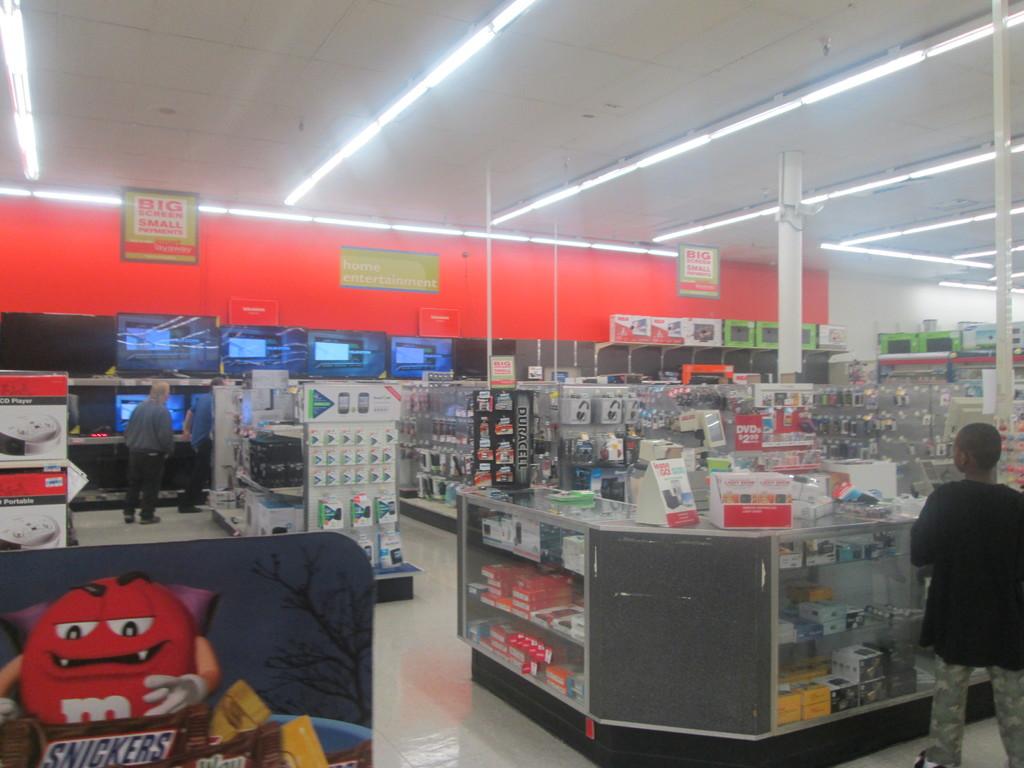What candy is advertised?
Make the answer very short. Snickers. 